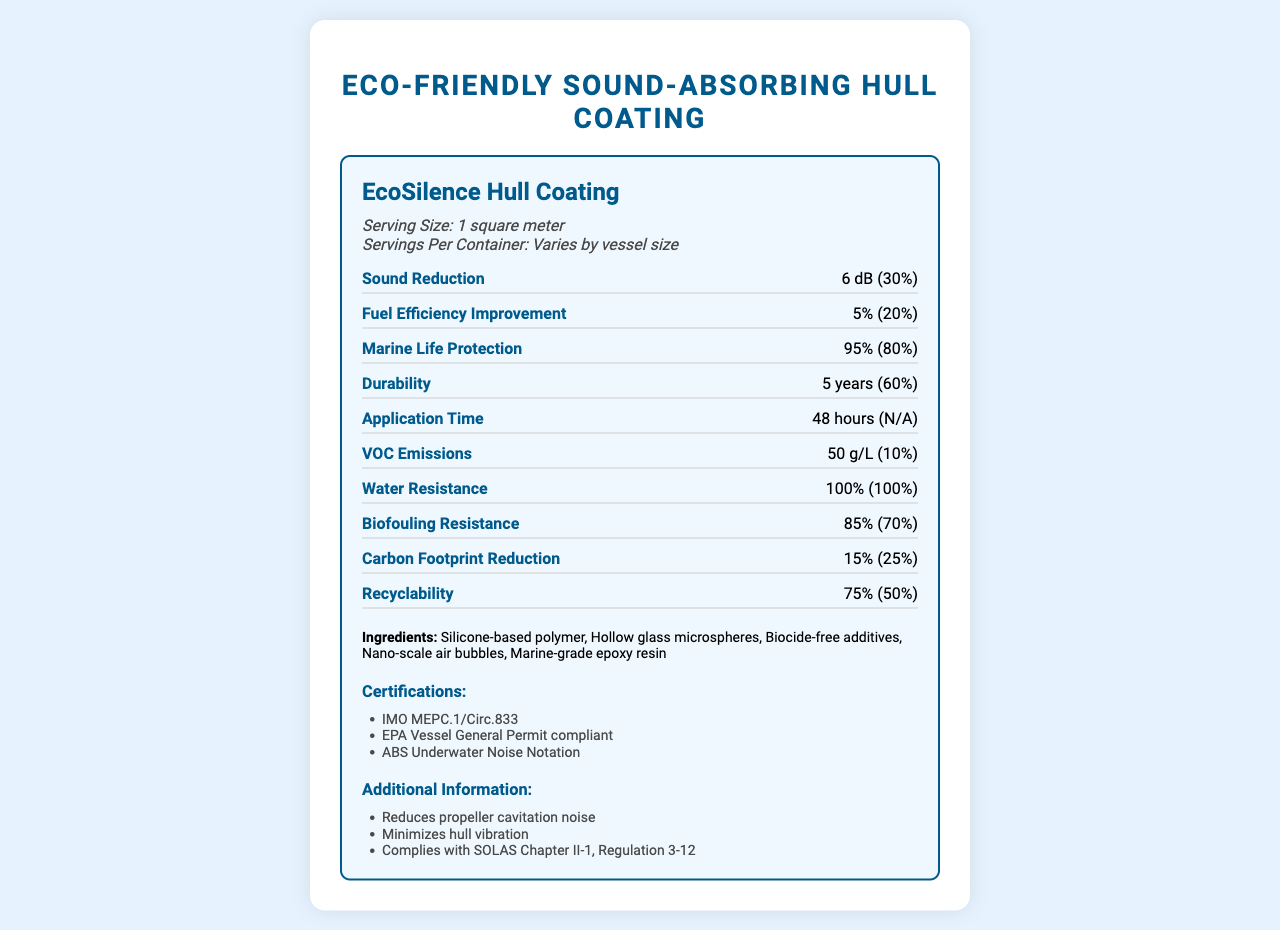what is the serving size for the EcoSilence Hull Coating? The serving size is clearly mentioned in the document under the product name and serving info section.
Answer: 1 square meter how long does it take to apply the EcoSilence Hull Coating? This information is given in the "Application Time" section of the document.
Answer: 48 hours what type of polymer is used in EcoSilence Hull Coating? The ingredient list in the document includes "Silicone-based polymer."
Answer: Silicone-based polymer how much sound reduction does the EcoSilence Hull Coating provide? This information is listed under the "Sound Reduction" section of the document.
Answer: 6 dB how many certifications does the EcoSilence Hull Coating have? The document lists three certifications under the "Certifications" section.
Answer: 3 which of the following is NOT listed as an ingredient of EcoSilence Hull Coating? A. Marine-grade epoxy resin B. Copper-based pesticide C. Hollow glass microspheres The ingredients list includes "Marine-grade epoxy resin" and "Hollow glass microspheres" but not "Copper-based pesticide."
Answer: B how effective is the EcoSilence Hull Coating at reducing carbon footprint? A. 15% B. 25% C. 50% Under "Carbon Footprint Reduction," it is stated that the hull coating reduces carbon footprint by 15%.
Answer: A does the EcoSilence Hull Coating comply with SOLAS Chapter II-1, Regulation 3-12? The additional information section states that the coating complies with SOLAS Chapter II-1, Regulation 3-12.
Answer: Yes summarize the main features and benefits of the EcoSilence Hull Coating. The document lists various technical specifications and benefits of the hull coating, including its ingredients, environmental impact, durability, and certifications.
Answer: The EcoSilence Hull Coating is a silicone-based, biocide-free hull coating that provides multiple benefits including reducing underwater sound emissions by 6 dB, improving fuel efficiency by 5%, protecting marine life by 95%, and having a durability of 5 years. It also has a high level of water resistance and biofouling resistance. The coating is environmentally friendly, offering a carbon footprint reduction of 15% and is 75% recyclable. It holds various certifications and complies with international maritime regulations. how much of the product's durability is represented as a percent daily value? The "Durability" section of the document shows that the percent daily value is 60%.
Answer: 60% is the document generated using Python code? The visual document does not contain any information about its origin or whether it was generated using Python code.
Answer: Not enough information 